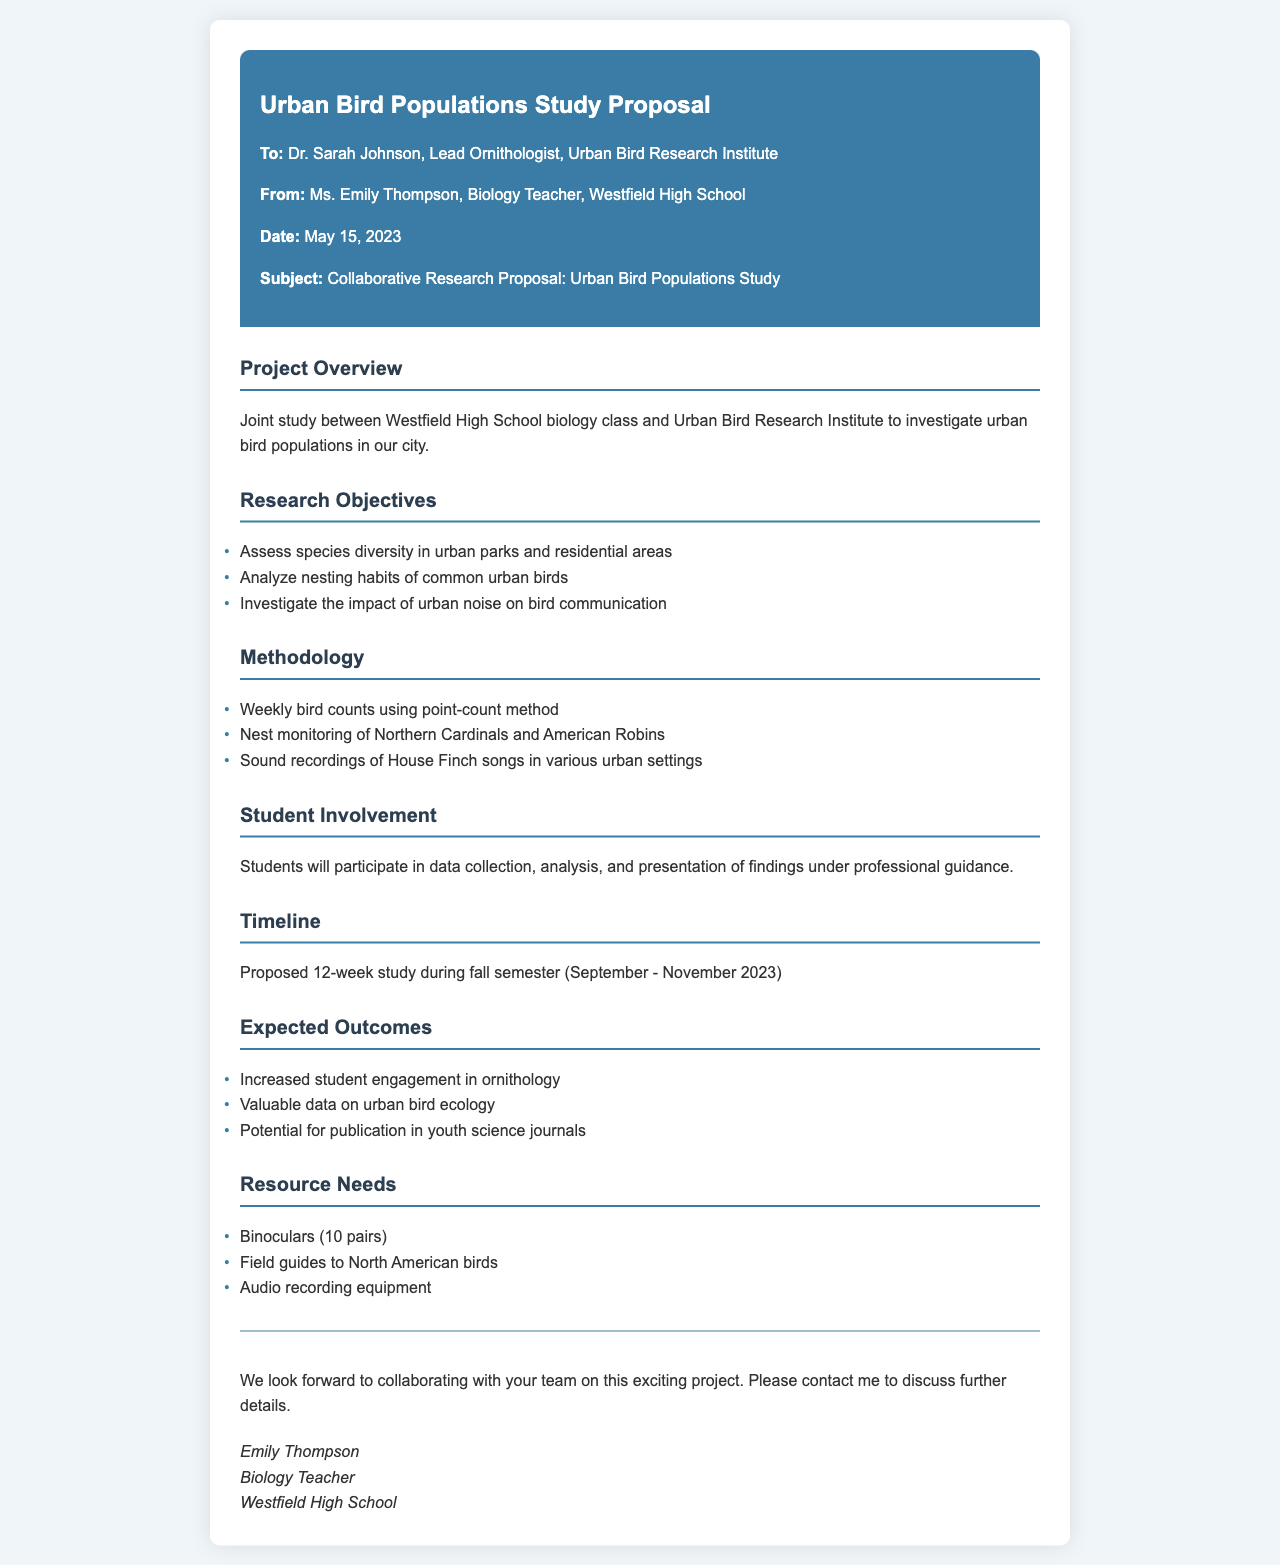What is the project title? The title of the project is given at the top of the document.
Answer: Urban Bird Populations Study Proposal Who is the lead ornithologist? The name of the lead ornithologist is mentioned in the fax.
Answer: Dr. Sarah Johnson When is the proposed study timeline? The timeline is specified in the document under the Timeline section.
Answer: September - November 2023 What is one of the research objectives? The document lists several objectives under Research Objectives.
Answer: Assess species diversity in urban parks and residential areas How many weeks is the study proposed to last? The duration of the study is stated in the Timeline section.
Answer: 12 weeks What is one type of equipment needed for the study? The Resource Needs section lists various equipment needed for the study.
Answer: Binoculars How will students participate in the study? The document explains student involvement in the Student Involvement section.
Answer: Data collection, analysis, and presentation What type of data is expected to be collected? The Expected Outcomes section mentions what will be gathered.
Answer: Valuable data on urban bird ecology What species will be monitored during the study? The species is mentioned in the Methodology section of the proposal.
Answer: Northern Cardinals and American Robins What is a potential outcome of the study? This is mentioned in the Expected Outcomes section of the document.
Answer: Potential for publication in youth science journals 